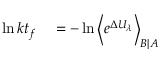Convert formula to latex. <formula><loc_0><loc_0><loc_500><loc_500>\begin{array} { r l } { \ln k t _ { f } } & = - \ln \left \langle e ^ { \Delta U _ { \lambda } } \right \rangle _ { B | A } } \end{array}</formula> 